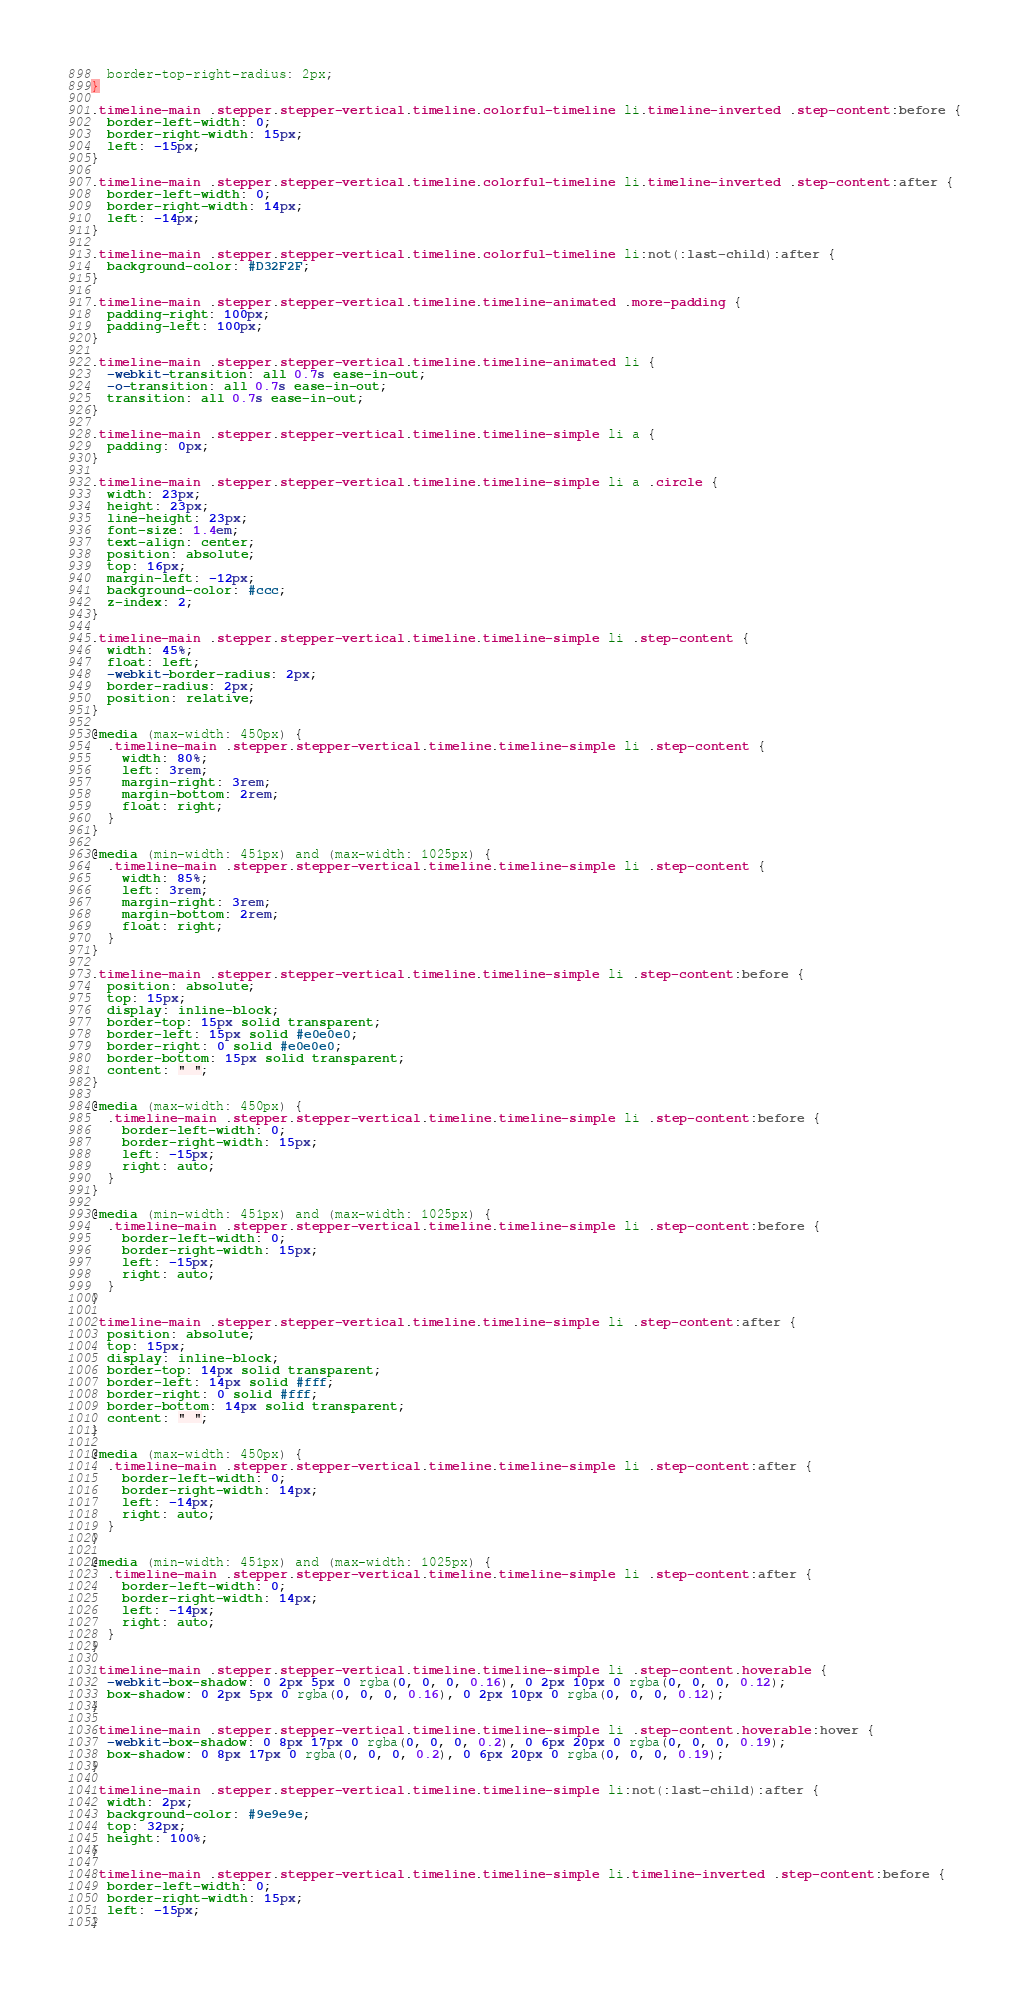Convert code to text. <code><loc_0><loc_0><loc_500><loc_500><_CSS_>  border-top-right-radius: 2px;
}

.timeline-main .stepper.stepper-vertical.timeline.colorful-timeline li.timeline-inverted .step-content:before {
  border-left-width: 0;
  border-right-width: 15px;
  left: -15px;
}

.timeline-main .stepper.stepper-vertical.timeline.colorful-timeline li.timeline-inverted .step-content:after {
  border-left-width: 0;
  border-right-width: 14px;
  left: -14px;
}

.timeline-main .stepper.stepper-vertical.timeline.colorful-timeline li:not(:last-child):after {
  background-color: #D32F2F;
}

.timeline-main .stepper.stepper-vertical.timeline.timeline-animated .more-padding {
  padding-right: 100px;
  padding-left: 100px;
}

.timeline-main .stepper.stepper-vertical.timeline.timeline-animated li {
  -webkit-transition: all 0.7s ease-in-out;
  -o-transition: all 0.7s ease-in-out;
  transition: all 0.7s ease-in-out;
}

.timeline-main .stepper.stepper-vertical.timeline.timeline-simple li a {
  padding: 0px;
}

.timeline-main .stepper.stepper-vertical.timeline.timeline-simple li a .circle {
  width: 23px;
  height: 23px;
  line-height: 23px;
  font-size: 1.4em;
  text-align: center;
  position: absolute;
  top: 16px;
  margin-left: -12px;
  background-color: #ccc;
  z-index: 2;
}

.timeline-main .stepper.stepper-vertical.timeline.timeline-simple li .step-content {
  width: 45%;
  float: left;
  -webkit-border-radius: 2px;
  border-radius: 2px;
  position: relative;
}

@media (max-width: 450px) {
  .timeline-main .stepper.stepper-vertical.timeline.timeline-simple li .step-content {
    width: 80%;
    left: 3rem;
    margin-right: 3rem;
    margin-bottom: 2rem;
    float: right;
  }
}

@media (min-width: 451px) and (max-width: 1025px) {
  .timeline-main .stepper.stepper-vertical.timeline.timeline-simple li .step-content {
    width: 85%;
    left: 3rem;
    margin-right: 3rem;
    margin-bottom: 2rem;
    float: right;
  }
}

.timeline-main .stepper.stepper-vertical.timeline.timeline-simple li .step-content:before {
  position: absolute;
  top: 15px;
  display: inline-block;
  border-top: 15px solid transparent;
  border-left: 15px solid #e0e0e0;
  border-right: 0 solid #e0e0e0;
  border-bottom: 15px solid transparent;
  content: " ";
}

@media (max-width: 450px) {
  .timeline-main .stepper.stepper-vertical.timeline.timeline-simple li .step-content:before {
    border-left-width: 0;
    border-right-width: 15px;
    left: -15px;
    right: auto;
  }
}

@media (min-width: 451px) and (max-width: 1025px) {
  .timeline-main .stepper.stepper-vertical.timeline.timeline-simple li .step-content:before {
    border-left-width: 0;
    border-right-width: 15px;
    left: -15px;
    right: auto;
  }
}

.timeline-main .stepper.stepper-vertical.timeline.timeline-simple li .step-content:after {
  position: absolute;
  top: 15px;
  display: inline-block;
  border-top: 14px solid transparent;
  border-left: 14px solid #fff;
  border-right: 0 solid #fff;
  border-bottom: 14px solid transparent;
  content: " ";
}

@media (max-width: 450px) {
  .timeline-main .stepper.stepper-vertical.timeline.timeline-simple li .step-content:after {
    border-left-width: 0;
    border-right-width: 14px;
    left: -14px;
    right: auto;
  }
}

@media (min-width: 451px) and (max-width: 1025px) {
  .timeline-main .stepper.stepper-vertical.timeline.timeline-simple li .step-content:after {
    border-left-width: 0;
    border-right-width: 14px;
    left: -14px;
    right: auto;
  }
}

.timeline-main .stepper.stepper-vertical.timeline.timeline-simple li .step-content.hoverable {
  -webkit-box-shadow: 0 2px 5px 0 rgba(0, 0, 0, 0.16), 0 2px 10px 0 rgba(0, 0, 0, 0.12);
  box-shadow: 0 2px 5px 0 rgba(0, 0, 0, 0.16), 0 2px 10px 0 rgba(0, 0, 0, 0.12);
}

.timeline-main .stepper.stepper-vertical.timeline.timeline-simple li .step-content.hoverable:hover {
  -webkit-box-shadow: 0 8px 17px 0 rgba(0, 0, 0, 0.2), 0 6px 20px 0 rgba(0, 0, 0, 0.19);
  box-shadow: 0 8px 17px 0 rgba(0, 0, 0, 0.2), 0 6px 20px 0 rgba(0, 0, 0, 0.19);
}

.timeline-main .stepper.stepper-vertical.timeline.timeline-simple li:not(:last-child):after {
  width: 2px;
  background-color: #9e9e9e;
  top: 32px;
  height: 100%;
}

.timeline-main .stepper.stepper-vertical.timeline.timeline-simple li.timeline-inverted .step-content:before {
  border-left-width: 0;
  border-right-width: 15px;
  left: -15px;
}
</code> 